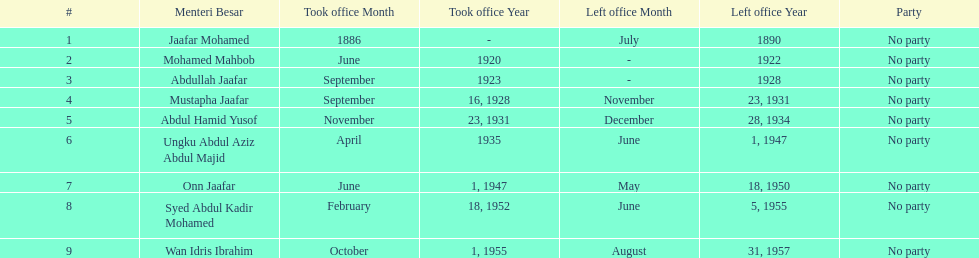How long did ungku abdul aziz abdul majid serve? 12 years. 